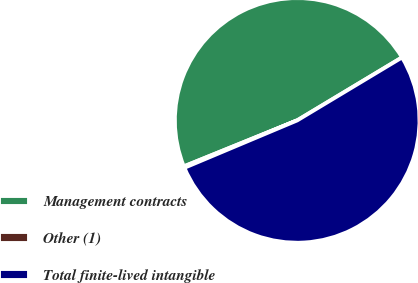<chart> <loc_0><loc_0><loc_500><loc_500><pie_chart><fcel>Management contracts<fcel>Other (1)<fcel>Total finite-lived intangible<nl><fcel>47.53%<fcel>0.19%<fcel>52.28%<nl></chart> 